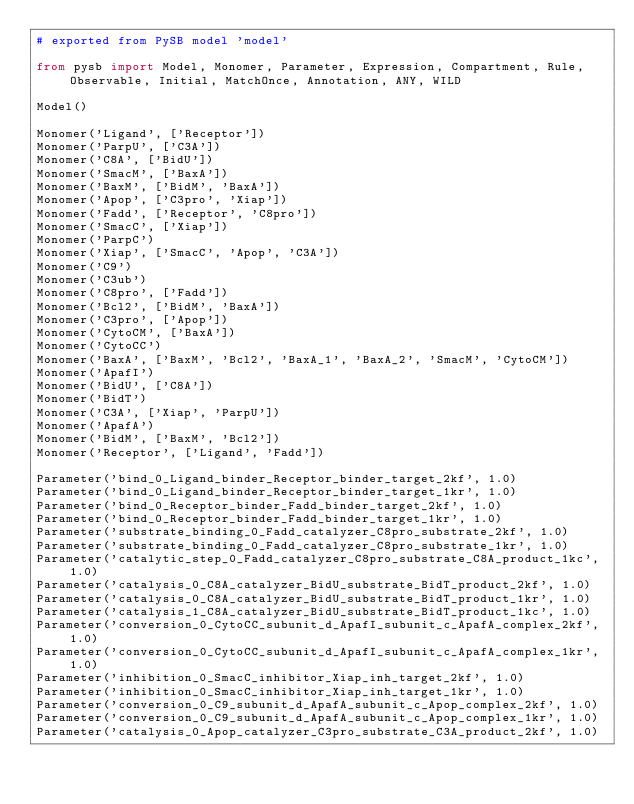<code> <loc_0><loc_0><loc_500><loc_500><_Python_># exported from PySB model 'model'

from pysb import Model, Monomer, Parameter, Expression, Compartment, Rule, Observable, Initial, MatchOnce, Annotation, ANY, WILD

Model()

Monomer('Ligand', ['Receptor'])
Monomer('ParpU', ['C3A'])
Monomer('C8A', ['BidU'])
Monomer('SmacM', ['BaxA'])
Monomer('BaxM', ['BidM', 'BaxA'])
Monomer('Apop', ['C3pro', 'Xiap'])
Monomer('Fadd', ['Receptor', 'C8pro'])
Monomer('SmacC', ['Xiap'])
Monomer('ParpC')
Monomer('Xiap', ['SmacC', 'Apop', 'C3A'])
Monomer('C9')
Monomer('C3ub')
Monomer('C8pro', ['Fadd'])
Monomer('Bcl2', ['BidM', 'BaxA'])
Monomer('C3pro', ['Apop'])
Monomer('CytoCM', ['BaxA'])
Monomer('CytoCC')
Monomer('BaxA', ['BaxM', 'Bcl2', 'BaxA_1', 'BaxA_2', 'SmacM', 'CytoCM'])
Monomer('ApafI')
Monomer('BidU', ['C8A'])
Monomer('BidT')
Monomer('C3A', ['Xiap', 'ParpU'])
Monomer('ApafA')
Monomer('BidM', ['BaxM', 'Bcl2'])
Monomer('Receptor', ['Ligand', 'Fadd'])

Parameter('bind_0_Ligand_binder_Receptor_binder_target_2kf', 1.0)
Parameter('bind_0_Ligand_binder_Receptor_binder_target_1kr', 1.0)
Parameter('bind_0_Receptor_binder_Fadd_binder_target_2kf', 1.0)
Parameter('bind_0_Receptor_binder_Fadd_binder_target_1kr', 1.0)
Parameter('substrate_binding_0_Fadd_catalyzer_C8pro_substrate_2kf', 1.0)
Parameter('substrate_binding_0_Fadd_catalyzer_C8pro_substrate_1kr', 1.0)
Parameter('catalytic_step_0_Fadd_catalyzer_C8pro_substrate_C8A_product_1kc', 1.0)
Parameter('catalysis_0_C8A_catalyzer_BidU_substrate_BidT_product_2kf', 1.0)
Parameter('catalysis_0_C8A_catalyzer_BidU_substrate_BidT_product_1kr', 1.0)
Parameter('catalysis_1_C8A_catalyzer_BidU_substrate_BidT_product_1kc', 1.0)
Parameter('conversion_0_CytoCC_subunit_d_ApafI_subunit_c_ApafA_complex_2kf', 1.0)
Parameter('conversion_0_CytoCC_subunit_d_ApafI_subunit_c_ApafA_complex_1kr', 1.0)
Parameter('inhibition_0_SmacC_inhibitor_Xiap_inh_target_2kf', 1.0)
Parameter('inhibition_0_SmacC_inhibitor_Xiap_inh_target_1kr', 1.0)
Parameter('conversion_0_C9_subunit_d_ApafA_subunit_c_Apop_complex_2kf', 1.0)
Parameter('conversion_0_C9_subunit_d_ApafA_subunit_c_Apop_complex_1kr', 1.0)
Parameter('catalysis_0_Apop_catalyzer_C3pro_substrate_C3A_product_2kf', 1.0)</code> 